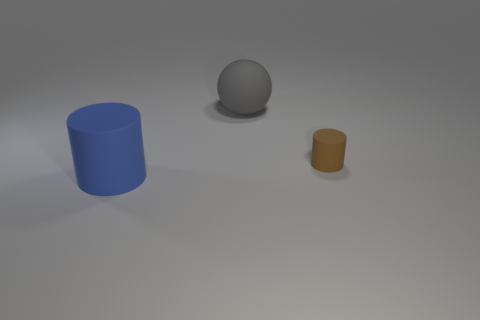Add 3 tiny metallic cylinders. How many objects exist? 6 Subtract all cylinders. How many objects are left? 1 Subtract 0 brown cubes. How many objects are left? 3 Subtract all tiny red things. Subtract all big objects. How many objects are left? 1 Add 3 large gray balls. How many large gray balls are left? 4 Add 2 small brown rubber things. How many small brown rubber things exist? 3 